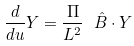Convert formula to latex. <formula><loc_0><loc_0><loc_500><loc_500>\frac { d } { d u } { Y } = \frac { \Pi } { L ^ { 2 } } \ \hat { B } \cdot { Y }</formula> 